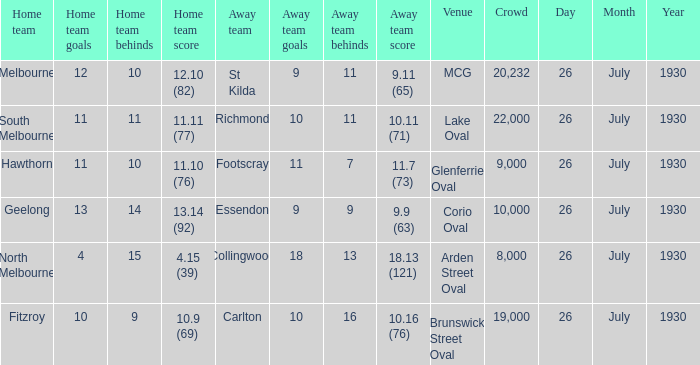When was Fitzroy the home team? 26 July 1930. 